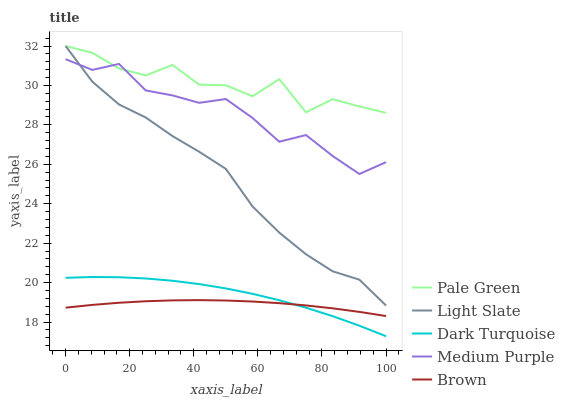Does Brown have the minimum area under the curve?
Answer yes or no. Yes. Does Pale Green have the maximum area under the curve?
Answer yes or no. Yes. Does Dark Turquoise have the minimum area under the curve?
Answer yes or no. No. Does Dark Turquoise have the maximum area under the curve?
Answer yes or no. No. Is Brown the smoothest?
Answer yes or no. Yes. Is Pale Green the roughest?
Answer yes or no. Yes. Is Dark Turquoise the smoothest?
Answer yes or no. No. Is Dark Turquoise the roughest?
Answer yes or no. No. Does Medium Purple have the lowest value?
Answer yes or no. No. Does Pale Green have the highest value?
Answer yes or no. Yes. Does Dark Turquoise have the highest value?
Answer yes or no. No. Is Dark Turquoise less than Medium Purple?
Answer yes or no. Yes. Is Pale Green greater than Dark Turquoise?
Answer yes or no. Yes. Does Pale Green intersect Light Slate?
Answer yes or no. Yes. Is Pale Green less than Light Slate?
Answer yes or no. No. Is Pale Green greater than Light Slate?
Answer yes or no. No. Does Dark Turquoise intersect Medium Purple?
Answer yes or no. No. 